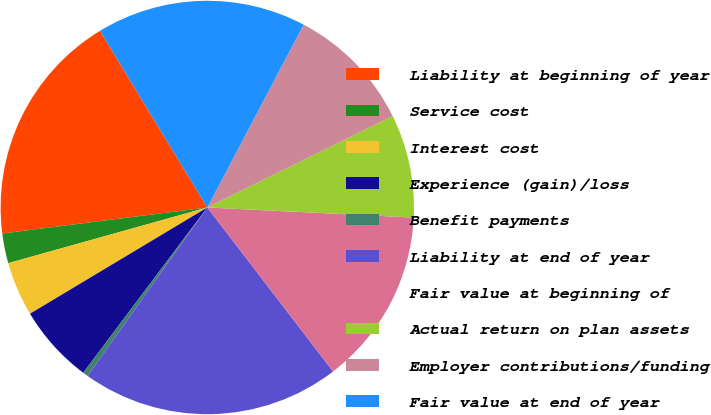<chart> <loc_0><loc_0><loc_500><loc_500><pie_chart><fcel>Liability at beginning of year<fcel>Service cost<fcel>Interest cost<fcel>Experience (gain)/loss<fcel>Benefit payments<fcel>Liability at end of year<fcel>Fair value at beginning of<fcel>Actual return on plan assets<fcel>Employer contributions/funding<fcel>Fair value at end of year<nl><fcel>18.32%<fcel>2.33%<fcel>4.25%<fcel>6.16%<fcel>0.42%<fcel>20.24%<fcel>13.81%<fcel>8.07%<fcel>9.99%<fcel>16.41%<nl></chart> 